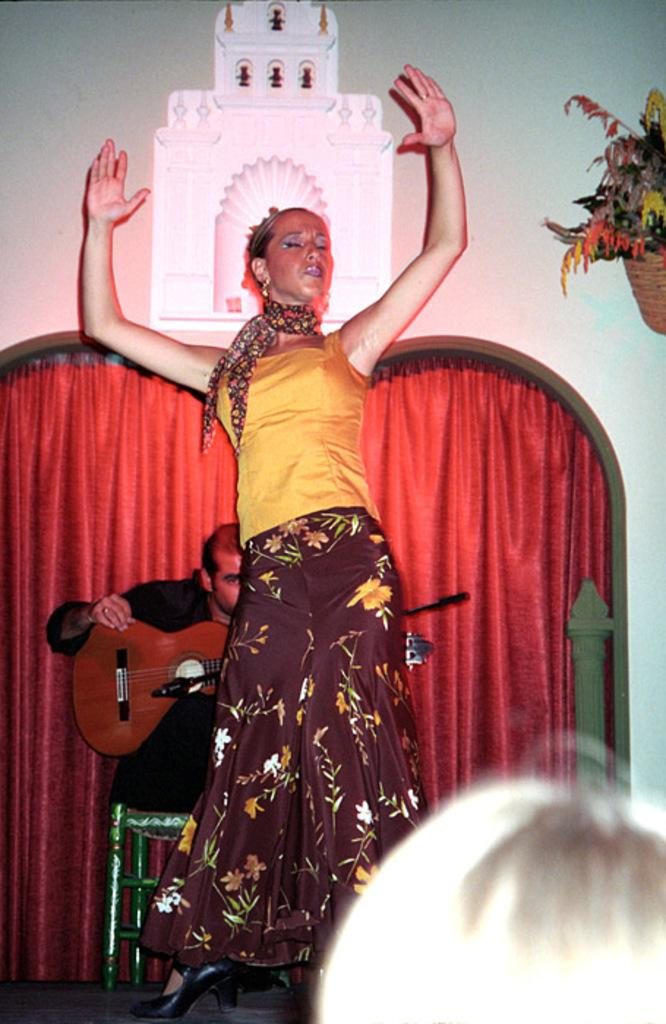What is the primary subject of the image? There is a woman standing in the image. Can you describe the person next to the woman? There is a person holding a guitar in the image. How many eggs are visible on the sheet in the image? There are no eggs or sheets present in the image. 